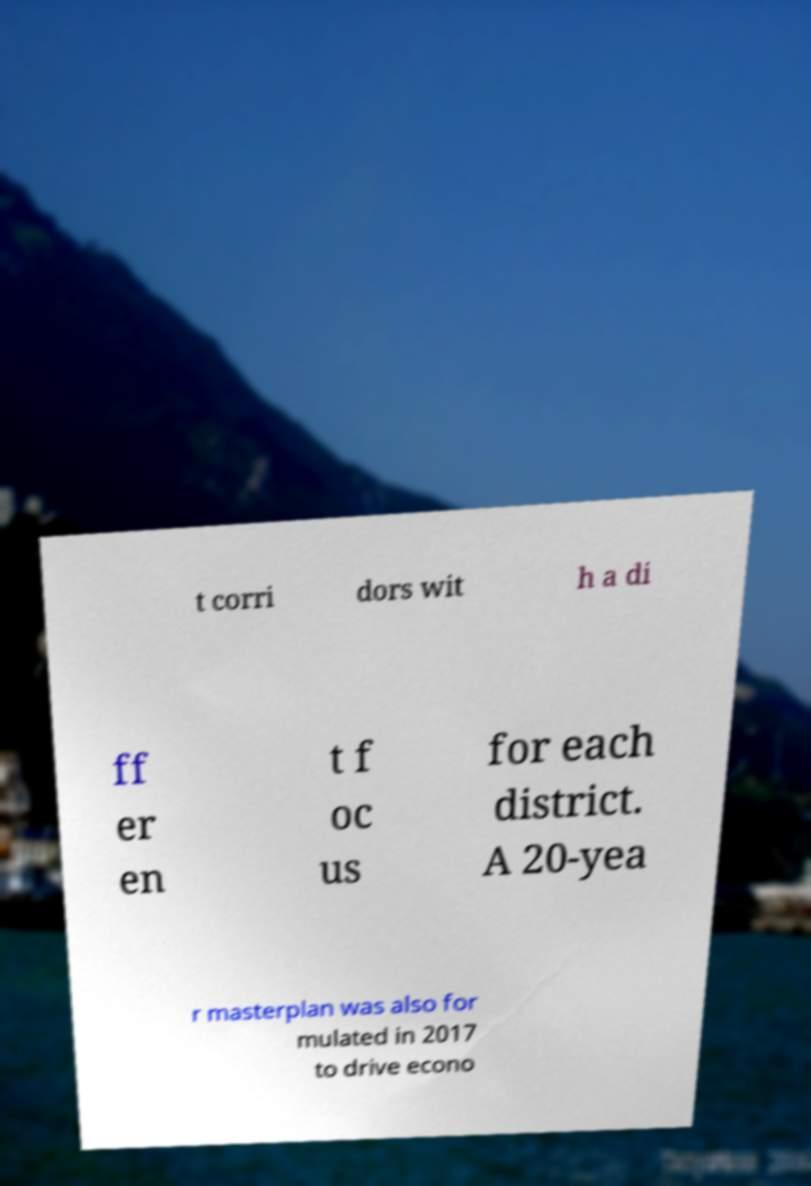Could you extract and type out the text from this image? t corri dors wit h a di ff er en t f oc us for each district. A 20-yea r masterplan was also for mulated in 2017 to drive econo 